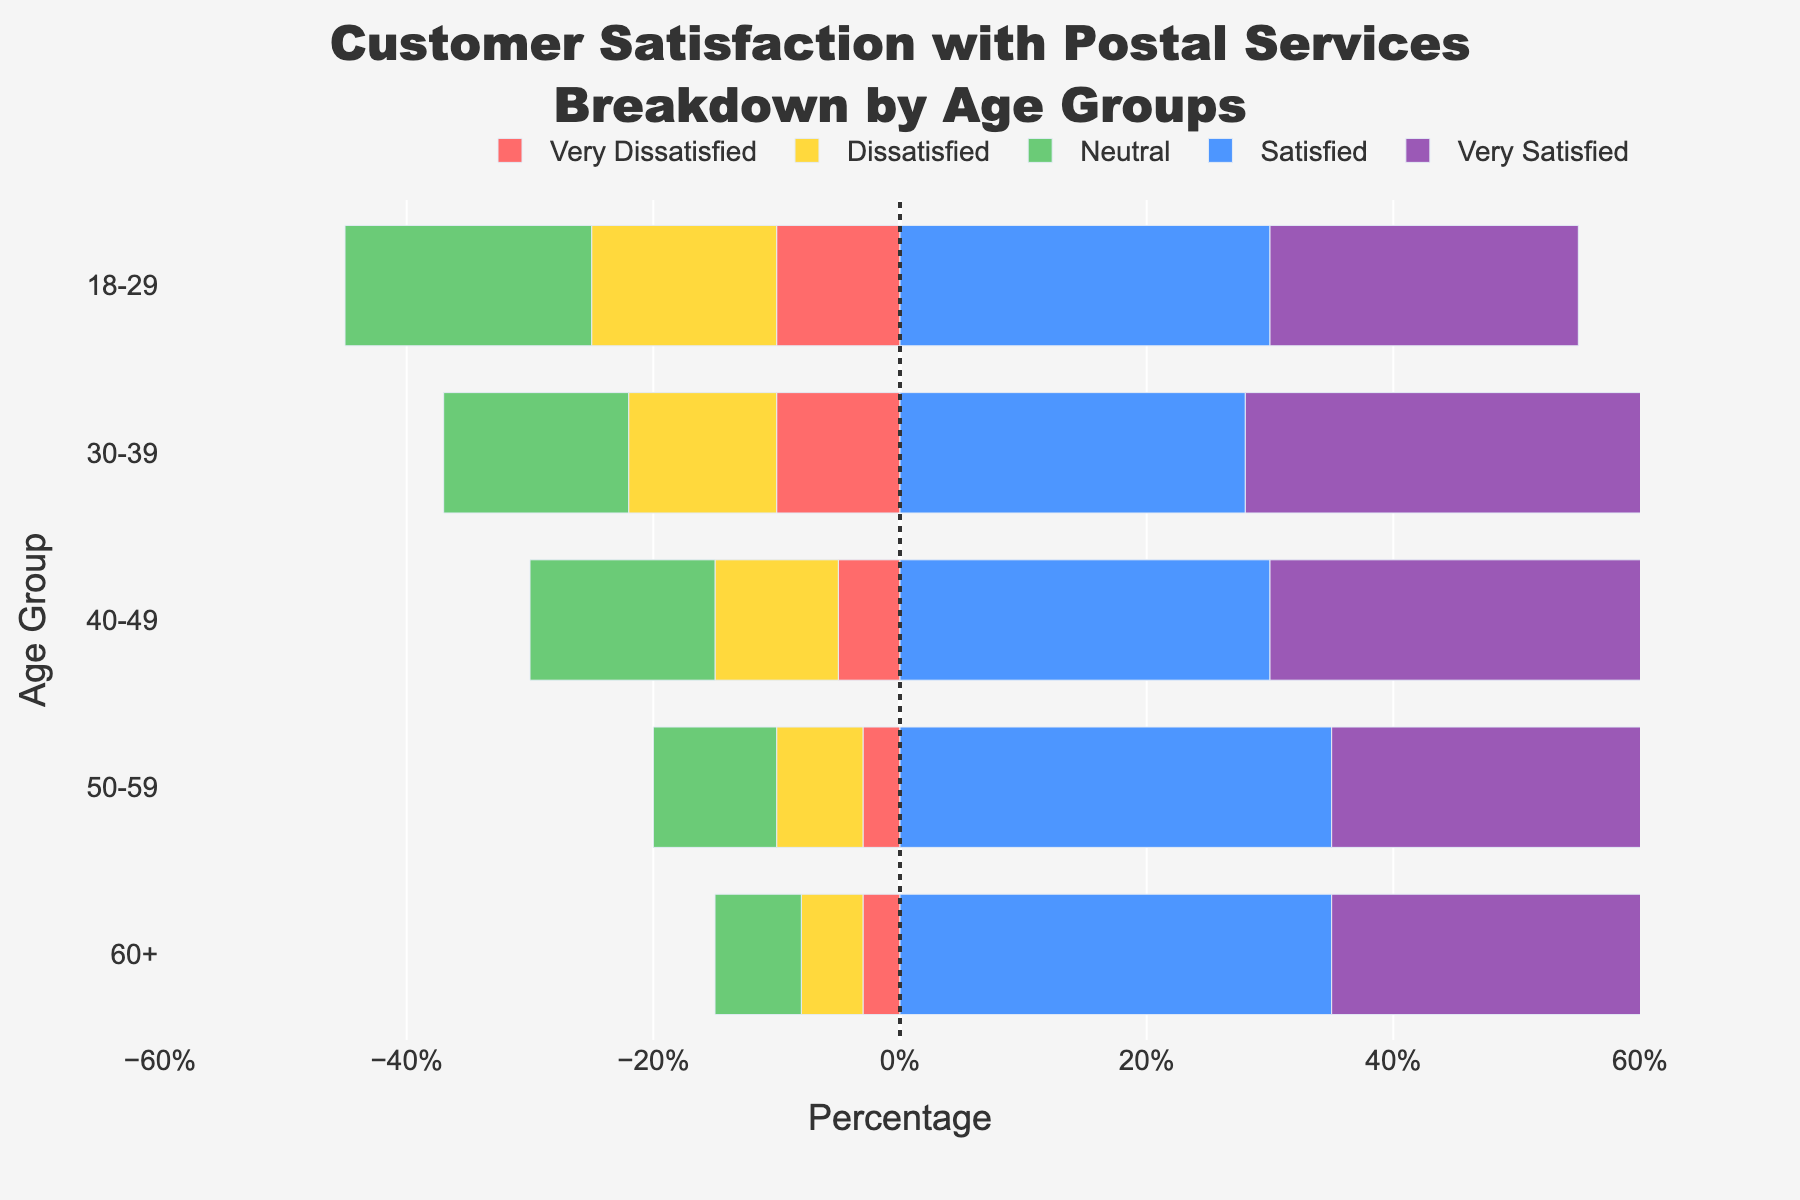Which age group has the highest percentage of 'Very Satisfied' customers? The bars for 'Very Satisfied' are positive and the longest bar in that category belongs to the 60+ age group with 50%.
Answer: 60+ How does the percentage of 'Dissatisfied' customers in the 18-29 age group compare to that in the 40-49 age group? By comparing the size of the 'Dissatisfied' bars, the 18-29 age group has a 15% bar, while the 40-49 age group has a 10% bar.
Answer: Greater in the 18-29 age group What is the total percentage of satisfied customers (Satisfied + Very Satisfied) in the 50-59 age group? For the 50-59 age group, 'Satisfied' is 35% and 'Very Satisfied' is 45%, totaling 35% + 45% = 80%.
Answer: 80% Which age group has the smallest percentage of 'Neutral' customers? By identifying the smallest bar in the 'Neutral' category, the 60+ group has the smallest percentage at 7%.
Answer: 60+ What are the positive values on the x-axis representing in the diverging bar chart? Positive values represent the percentages of customers who are 'Satisfied' or 'Very Satisfied' across different age groups.
Answer: Satisfied and Very Satisfied Calculate the combined percentage of 'Dissatisfied' and 'Very Dissatisfied' customers for the 30-39 age group. The 'Dissatisfied' percentage is 12%, and 'Very Dissatisfied' is 10%, combining for 12% + 10% = 22%.
Answer: 22% Which satisfaction category is represented by the purple bars? Observing the chart, the purple bars correspond to the 'Very Satisfied' category.
Answer: Very Satisfied What is the difference in the percentage of 'Very Dissatisfied' customers between the 18-29 and the 60+ age groups? The 18-29 age group has 10% 'Very Dissatisfied,' and the 60+ age group has 3%, resulting in a difference of 10% - 3% = 7%.
Answer: 7% Is there any age group where the percentage of 'Neutral' customers is higher than the percentage of 'Dissatisfied' customers? By comparing bars for each age group, the 18-29 age group shows a 20% 'Neutral' and a 15% 'Dissatisfied' percentage, which meets this condition.
Answer: Yes, 18-29 age group Rank the age groups from highest to lowest percentage of 'Satisfied' customers. By checking the lengths of the 'Satisfied' bars: 50-59 (35%), 60+ (35%), 18-29 (30%), 40-49 (30%), 30-39 (28%).
Answer: 50-59 & 60+, 18-29 & 40-49, 30-39 